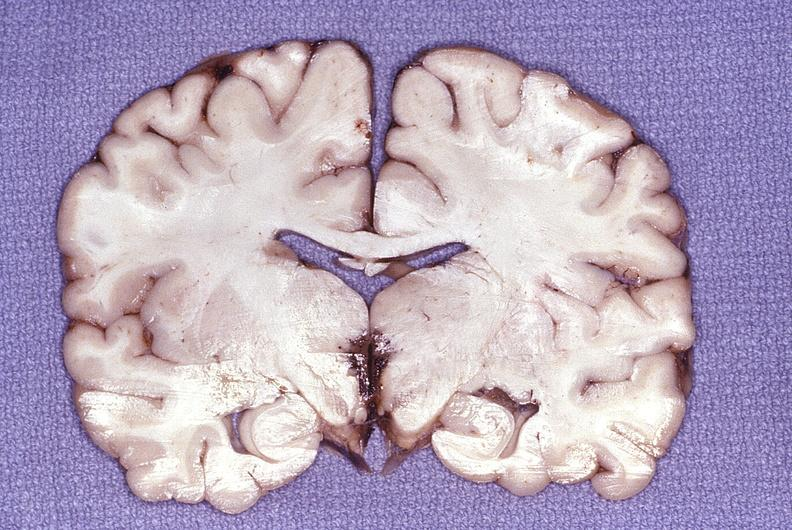what is present?
Answer the question using a single word or phrase. Nervous 